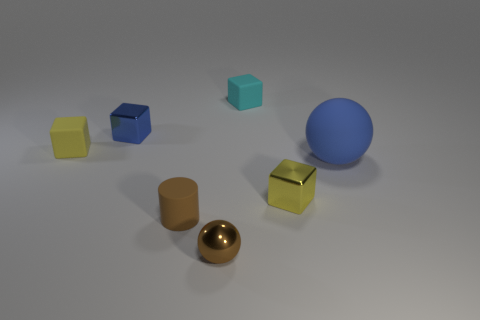How many objects are either small brown spheres or tiny metal blocks left of the small cyan matte thing?
Offer a terse response. 2. How many matte balls are there?
Offer a very short reply. 1. Are there any brown things of the same size as the cyan matte thing?
Your response must be concise. Yes. Is the number of small objects that are in front of the small brown metal thing less than the number of tiny yellow blocks?
Provide a short and direct response. Yes. Is the size of the brown shiny thing the same as the brown cylinder?
Your answer should be compact. Yes. What is the size of the blue thing that is the same material as the tiny brown cylinder?
Provide a short and direct response. Large. How many other cylinders are the same color as the cylinder?
Your response must be concise. 0. Is the number of brown metal objects that are in front of the yellow metal cube less than the number of small matte objects behind the tiny brown cylinder?
Provide a short and direct response. Yes. There is a yellow object left of the tiny cyan matte object; is its shape the same as the tiny cyan matte thing?
Provide a short and direct response. Yes. Does the blue object that is in front of the yellow rubber block have the same material as the tiny blue block?
Your response must be concise. No. 